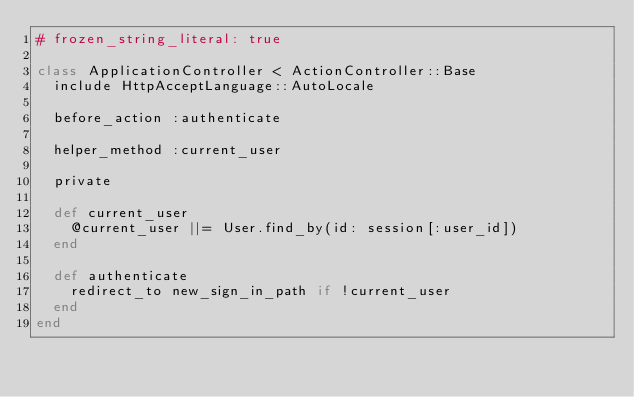Convert code to text. <code><loc_0><loc_0><loc_500><loc_500><_Ruby_># frozen_string_literal: true

class ApplicationController < ActionController::Base
  include HttpAcceptLanguage::AutoLocale

  before_action :authenticate

  helper_method :current_user

  private

  def current_user
    @current_user ||= User.find_by(id: session[:user_id])
  end

  def authenticate
    redirect_to new_sign_in_path if !current_user
  end
end
</code> 